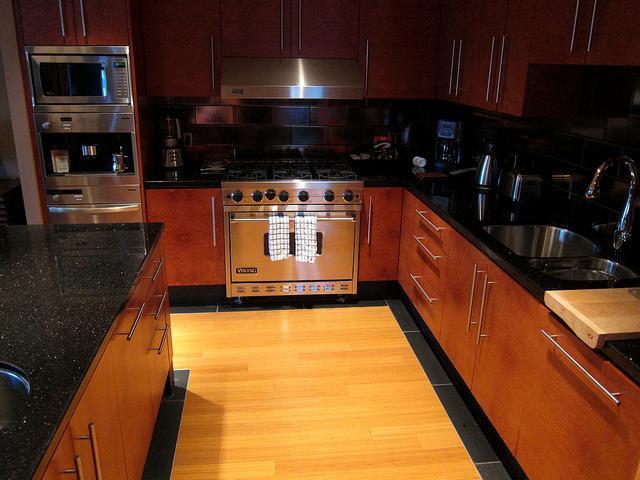How many towels are there?
Give a very brief answer. 2. How many sinks are visible?
Give a very brief answer. 2. How many ovens are in the photo?
Give a very brief answer. 2. 